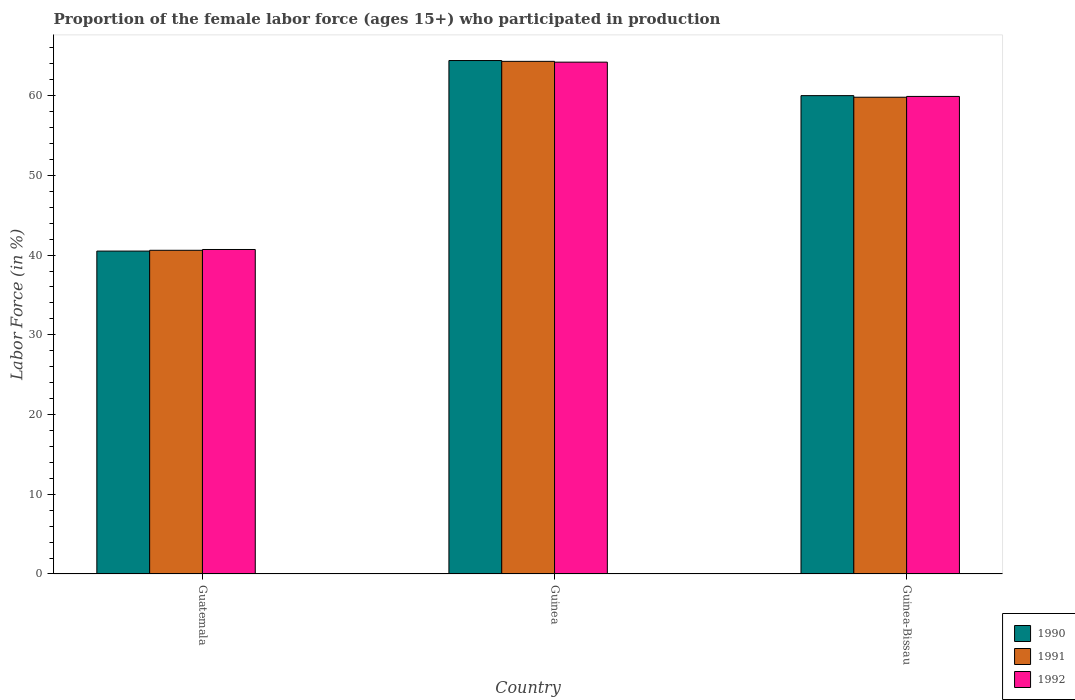Are the number of bars on each tick of the X-axis equal?
Keep it short and to the point. Yes. How many bars are there on the 1st tick from the right?
Offer a very short reply. 3. What is the label of the 3rd group of bars from the left?
Offer a terse response. Guinea-Bissau. What is the proportion of the female labor force who participated in production in 1992 in Guinea-Bissau?
Offer a very short reply. 59.9. Across all countries, what is the maximum proportion of the female labor force who participated in production in 1991?
Offer a very short reply. 64.3. Across all countries, what is the minimum proportion of the female labor force who participated in production in 1990?
Offer a very short reply. 40.5. In which country was the proportion of the female labor force who participated in production in 1991 maximum?
Offer a terse response. Guinea. In which country was the proportion of the female labor force who participated in production in 1990 minimum?
Ensure brevity in your answer.  Guatemala. What is the total proportion of the female labor force who participated in production in 1990 in the graph?
Make the answer very short. 164.9. What is the difference between the proportion of the female labor force who participated in production in 1991 in Guinea and that in Guinea-Bissau?
Your answer should be compact. 4.5. What is the difference between the proportion of the female labor force who participated in production in 1992 in Guinea-Bissau and the proportion of the female labor force who participated in production in 1990 in Guinea?
Make the answer very short. -4.5. What is the average proportion of the female labor force who participated in production in 1990 per country?
Offer a terse response. 54.97. What is the difference between the proportion of the female labor force who participated in production of/in 1992 and proportion of the female labor force who participated in production of/in 1991 in Guatemala?
Offer a very short reply. 0.1. What is the ratio of the proportion of the female labor force who participated in production in 1991 in Guatemala to that in Guinea?
Provide a short and direct response. 0.63. Is the difference between the proportion of the female labor force who participated in production in 1992 in Guatemala and Guinea-Bissau greater than the difference between the proportion of the female labor force who participated in production in 1991 in Guatemala and Guinea-Bissau?
Offer a terse response. No. What is the difference between the highest and the second highest proportion of the female labor force who participated in production in 1992?
Provide a short and direct response. 23.5. What is the difference between the highest and the lowest proportion of the female labor force who participated in production in 1990?
Make the answer very short. 23.9. What does the 1st bar from the left in Guatemala represents?
Provide a short and direct response. 1990. What does the 3rd bar from the right in Guinea-Bissau represents?
Your response must be concise. 1990. How many bars are there?
Keep it short and to the point. 9. Are all the bars in the graph horizontal?
Your answer should be compact. No. Are the values on the major ticks of Y-axis written in scientific E-notation?
Your answer should be compact. No. Where does the legend appear in the graph?
Make the answer very short. Bottom right. How many legend labels are there?
Provide a succinct answer. 3. What is the title of the graph?
Provide a short and direct response. Proportion of the female labor force (ages 15+) who participated in production. Does "2002" appear as one of the legend labels in the graph?
Give a very brief answer. No. What is the Labor Force (in %) of 1990 in Guatemala?
Offer a very short reply. 40.5. What is the Labor Force (in %) in 1991 in Guatemala?
Make the answer very short. 40.6. What is the Labor Force (in %) in 1992 in Guatemala?
Your answer should be very brief. 40.7. What is the Labor Force (in %) of 1990 in Guinea?
Make the answer very short. 64.4. What is the Labor Force (in %) in 1991 in Guinea?
Provide a succinct answer. 64.3. What is the Labor Force (in %) of 1992 in Guinea?
Provide a succinct answer. 64.2. What is the Labor Force (in %) in 1991 in Guinea-Bissau?
Your answer should be compact. 59.8. What is the Labor Force (in %) in 1992 in Guinea-Bissau?
Offer a very short reply. 59.9. Across all countries, what is the maximum Labor Force (in %) in 1990?
Keep it short and to the point. 64.4. Across all countries, what is the maximum Labor Force (in %) of 1991?
Keep it short and to the point. 64.3. Across all countries, what is the maximum Labor Force (in %) of 1992?
Your answer should be compact. 64.2. Across all countries, what is the minimum Labor Force (in %) in 1990?
Your response must be concise. 40.5. Across all countries, what is the minimum Labor Force (in %) of 1991?
Make the answer very short. 40.6. Across all countries, what is the minimum Labor Force (in %) of 1992?
Your response must be concise. 40.7. What is the total Labor Force (in %) in 1990 in the graph?
Offer a terse response. 164.9. What is the total Labor Force (in %) in 1991 in the graph?
Offer a very short reply. 164.7. What is the total Labor Force (in %) of 1992 in the graph?
Your answer should be very brief. 164.8. What is the difference between the Labor Force (in %) in 1990 in Guatemala and that in Guinea?
Your response must be concise. -23.9. What is the difference between the Labor Force (in %) in 1991 in Guatemala and that in Guinea?
Offer a very short reply. -23.7. What is the difference between the Labor Force (in %) in 1992 in Guatemala and that in Guinea?
Your answer should be very brief. -23.5. What is the difference between the Labor Force (in %) of 1990 in Guatemala and that in Guinea-Bissau?
Ensure brevity in your answer.  -19.5. What is the difference between the Labor Force (in %) of 1991 in Guatemala and that in Guinea-Bissau?
Your answer should be compact. -19.2. What is the difference between the Labor Force (in %) of 1992 in Guatemala and that in Guinea-Bissau?
Provide a succinct answer. -19.2. What is the difference between the Labor Force (in %) of 1991 in Guinea and that in Guinea-Bissau?
Keep it short and to the point. 4.5. What is the difference between the Labor Force (in %) of 1992 in Guinea and that in Guinea-Bissau?
Make the answer very short. 4.3. What is the difference between the Labor Force (in %) in 1990 in Guatemala and the Labor Force (in %) in 1991 in Guinea?
Keep it short and to the point. -23.8. What is the difference between the Labor Force (in %) in 1990 in Guatemala and the Labor Force (in %) in 1992 in Guinea?
Your response must be concise. -23.7. What is the difference between the Labor Force (in %) in 1991 in Guatemala and the Labor Force (in %) in 1992 in Guinea?
Give a very brief answer. -23.6. What is the difference between the Labor Force (in %) of 1990 in Guatemala and the Labor Force (in %) of 1991 in Guinea-Bissau?
Make the answer very short. -19.3. What is the difference between the Labor Force (in %) of 1990 in Guatemala and the Labor Force (in %) of 1992 in Guinea-Bissau?
Ensure brevity in your answer.  -19.4. What is the difference between the Labor Force (in %) of 1991 in Guatemala and the Labor Force (in %) of 1992 in Guinea-Bissau?
Ensure brevity in your answer.  -19.3. What is the difference between the Labor Force (in %) of 1990 in Guinea and the Labor Force (in %) of 1992 in Guinea-Bissau?
Offer a very short reply. 4.5. What is the average Labor Force (in %) of 1990 per country?
Give a very brief answer. 54.97. What is the average Labor Force (in %) in 1991 per country?
Ensure brevity in your answer.  54.9. What is the average Labor Force (in %) in 1992 per country?
Offer a very short reply. 54.93. What is the difference between the Labor Force (in %) of 1990 and Labor Force (in %) of 1992 in Guatemala?
Offer a very short reply. -0.2. What is the difference between the Labor Force (in %) in 1990 and Labor Force (in %) in 1992 in Guinea?
Give a very brief answer. 0.2. What is the difference between the Labor Force (in %) in 1991 and Labor Force (in %) in 1992 in Guinea?
Your answer should be very brief. 0.1. What is the difference between the Labor Force (in %) in 1990 and Labor Force (in %) in 1991 in Guinea-Bissau?
Provide a succinct answer. 0.2. What is the difference between the Labor Force (in %) in 1990 and Labor Force (in %) in 1992 in Guinea-Bissau?
Your answer should be compact. 0.1. What is the difference between the Labor Force (in %) of 1991 and Labor Force (in %) of 1992 in Guinea-Bissau?
Give a very brief answer. -0.1. What is the ratio of the Labor Force (in %) of 1990 in Guatemala to that in Guinea?
Offer a very short reply. 0.63. What is the ratio of the Labor Force (in %) in 1991 in Guatemala to that in Guinea?
Provide a succinct answer. 0.63. What is the ratio of the Labor Force (in %) in 1992 in Guatemala to that in Guinea?
Offer a terse response. 0.63. What is the ratio of the Labor Force (in %) in 1990 in Guatemala to that in Guinea-Bissau?
Keep it short and to the point. 0.68. What is the ratio of the Labor Force (in %) in 1991 in Guatemala to that in Guinea-Bissau?
Your answer should be very brief. 0.68. What is the ratio of the Labor Force (in %) of 1992 in Guatemala to that in Guinea-Bissau?
Offer a terse response. 0.68. What is the ratio of the Labor Force (in %) in 1990 in Guinea to that in Guinea-Bissau?
Keep it short and to the point. 1.07. What is the ratio of the Labor Force (in %) of 1991 in Guinea to that in Guinea-Bissau?
Your answer should be compact. 1.08. What is the ratio of the Labor Force (in %) of 1992 in Guinea to that in Guinea-Bissau?
Ensure brevity in your answer.  1.07. What is the difference between the highest and the second highest Labor Force (in %) in 1990?
Offer a very short reply. 4.4. What is the difference between the highest and the lowest Labor Force (in %) of 1990?
Provide a short and direct response. 23.9. What is the difference between the highest and the lowest Labor Force (in %) in 1991?
Give a very brief answer. 23.7. 